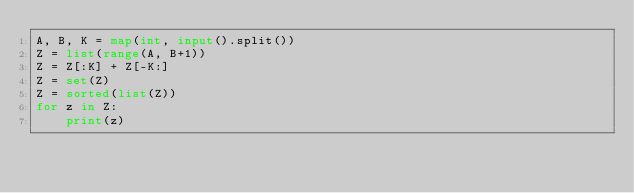<code> <loc_0><loc_0><loc_500><loc_500><_Python_>A, B, K = map(int, input().split())
Z = list(range(A, B+1))
Z = Z[:K] + Z[-K:]
Z = set(Z)
Z = sorted(list(Z))
for z in Z:
    print(z)</code> 